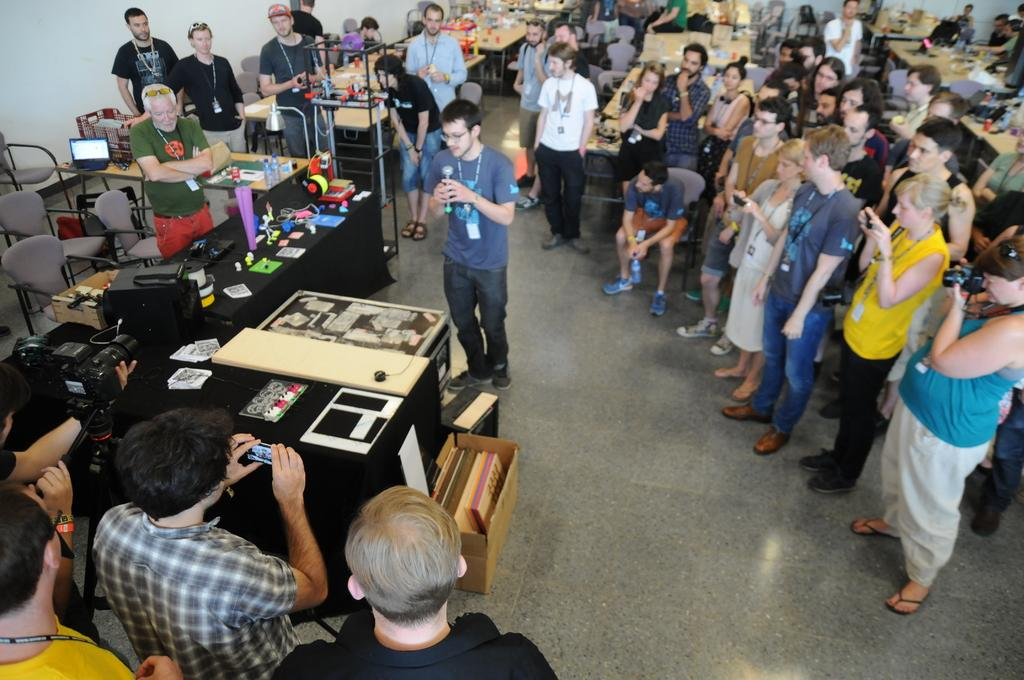What is the color of the wall in the image? The wall in the image is white. What can be seen in front of the wall? There are people standing in the image. What type of furniture is present in the image? There are chairs and tables in the image. What type of wood is the scarecrow made of in the image? There is no scarecrow present in the image, so it cannot be determined what type of wood it might be made of. 